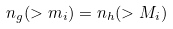Convert formula to latex. <formula><loc_0><loc_0><loc_500><loc_500>n _ { g } ( > m _ { i } ) = n _ { h } ( > M _ { i } )</formula> 